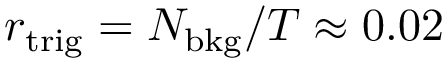Convert formula to latex. <formula><loc_0><loc_0><loc_500><loc_500>r _ { t r i g } = N _ { b k g } / T \approx 0 . 0 2</formula> 